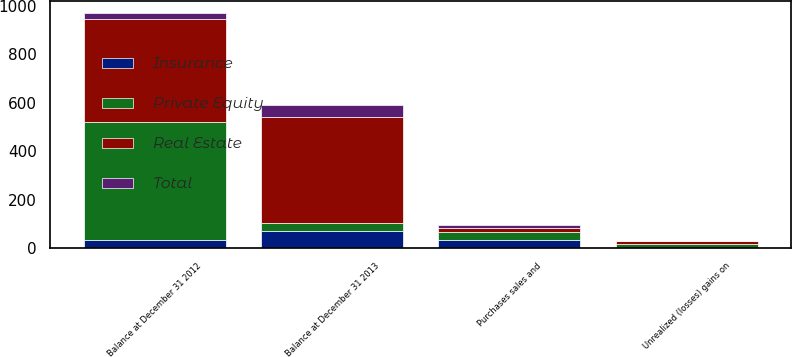Convert chart to OTSL. <chart><loc_0><loc_0><loc_500><loc_500><stacked_bar_chart><ecel><fcel>Unrealized (losses) gains on<fcel>Balance at December 31 2012<fcel>Purchases sales and<fcel>Balance at December 31 2013<nl><fcel>Real Estate<fcel>13<fcel>424<fcel>13<fcel>440<nl><fcel>Insurance<fcel>1<fcel>34<fcel>33<fcel>69<nl><fcel>Total<fcel>1<fcel>28<fcel>15<fcel>48<nl><fcel>Private Equity<fcel>15<fcel>486<fcel>35<fcel>33<nl></chart> 